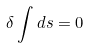Convert formula to latex. <formula><loc_0><loc_0><loc_500><loc_500>\delta \int d s = 0</formula> 